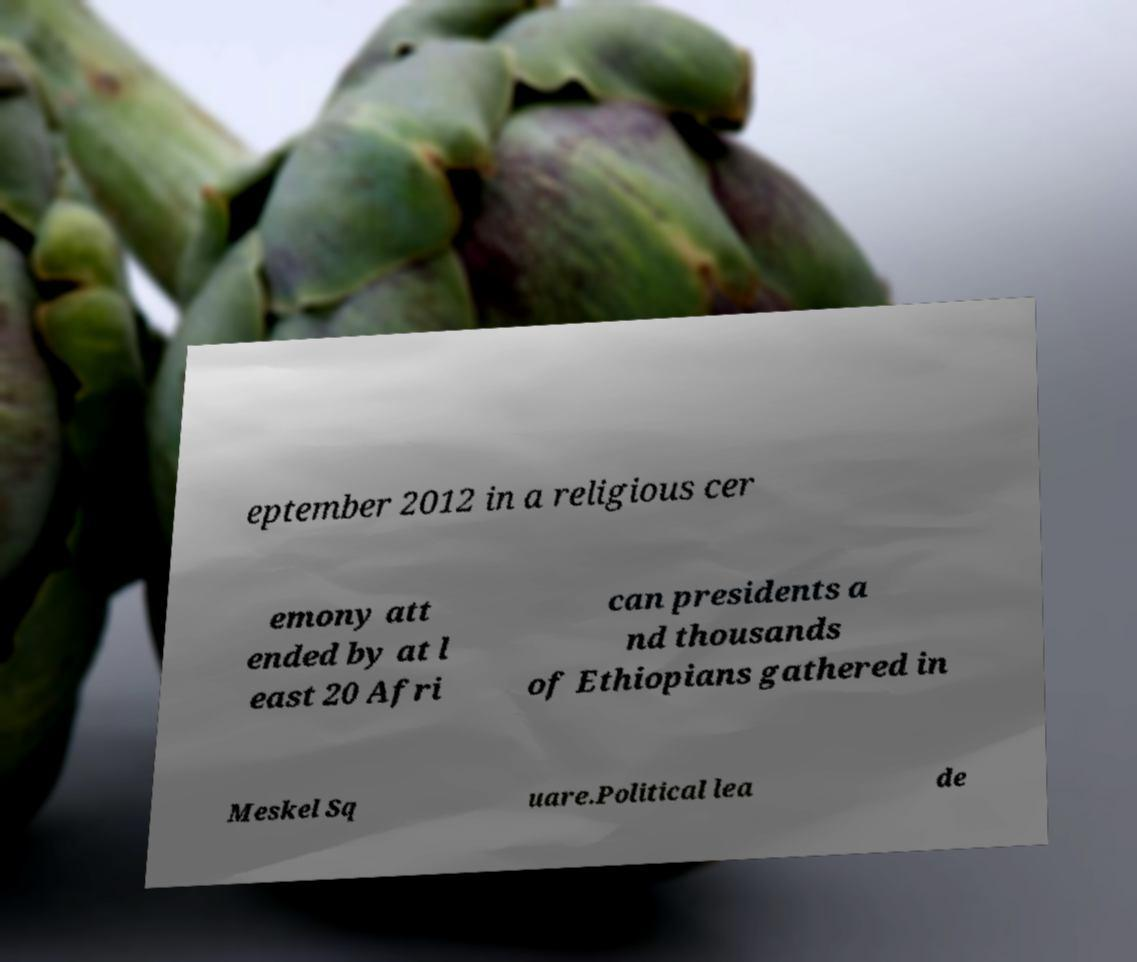Could you extract and type out the text from this image? eptember 2012 in a religious cer emony att ended by at l east 20 Afri can presidents a nd thousands of Ethiopians gathered in Meskel Sq uare.Political lea de 